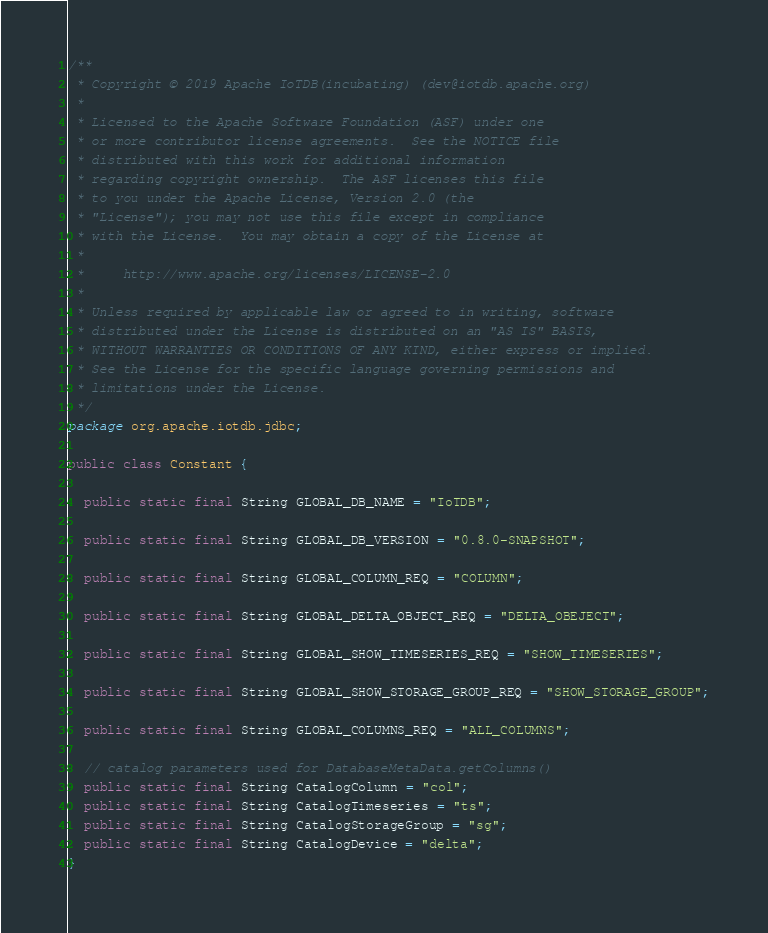Convert code to text. <code><loc_0><loc_0><loc_500><loc_500><_Java_>/**
 * Copyright © 2019 Apache IoTDB(incubating) (dev@iotdb.apache.org)
 *
 * Licensed to the Apache Software Foundation (ASF) under one
 * or more contributor license agreements.  See the NOTICE file
 * distributed with this work for additional information
 * regarding copyright ownership.  The ASF licenses this file
 * to you under the Apache License, Version 2.0 (the
 * "License"); you may not use this file except in compliance
 * with the License.  You may obtain a copy of the License at
 *
 *     http://www.apache.org/licenses/LICENSE-2.0
 *
 * Unless required by applicable law or agreed to in writing, software
 * distributed under the License is distributed on an "AS IS" BASIS,
 * WITHOUT WARRANTIES OR CONDITIONS OF ANY KIND, either express or implied.
 * See the License for the specific language governing permissions and
 * limitations under the License.
 */
package org.apache.iotdb.jdbc;

public class Constant {

  public static final String GLOBAL_DB_NAME = "IoTDB";

  public static final String GLOBAL_DB_VERSION = "0.8.0-SNAPSHOT";

  public static final String GLOBAL_COLUMN_REQ = "COLUMN";

  public static final String GLOBAL_DELTA_OBJECT_REQ = "DELTA_OBEJECT";

  public static final String GLOBAL_SHOW_TIMESERIES_REQ = "SHOW_TIMESERIES";

  public static final String GLOBAL_SHOW_STORAGE_GROUP_REQ = "SHOW_STORAGE_GROUP";

  public static final String GLOBAL_COLUMNS_REQ = "ALL_COLUMNS";

  // catalog parameters used for DatabaseMetaData.getColumns()
  public static final String CatalogColumn = "col";
  public static final String CatalogTimeseries = "ts";
  public static final String CatalogStorageGroup = "sg";
  public static final String CatalogDevice = "delta";
}
</code> 